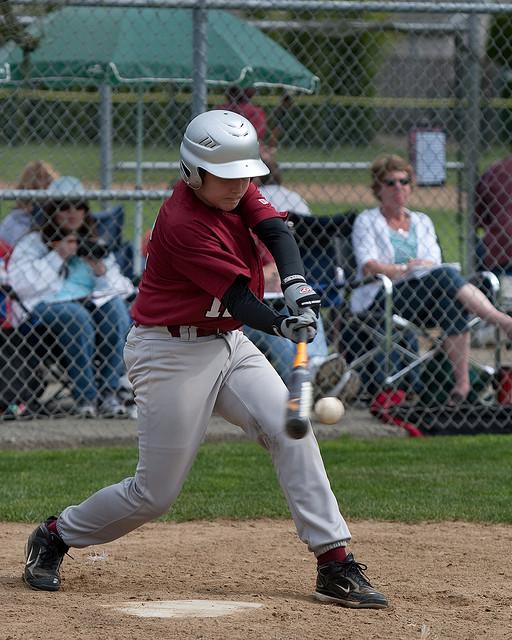What color is his helmet?
Short answer required. Silver. How many shin pads does he have?
Keep it brief. 0. It's the ball traveling toward our away from the bat?
Write a very short answer. Toward. What color is the umbrella?
Concise answer only. Green. What is the boy's number?
Concise answer only. 11. What color is the shirt the man is wearing?
Concise answer only. Red. Who is behind the fence?
Short answer required. Spectators. Is the headgear meant to protect him from rain?
Answer briefly. No. Who is the batter?
Keep it brief. Boy. Is the batter a child or an adult?
Write a very short answer. Child. 